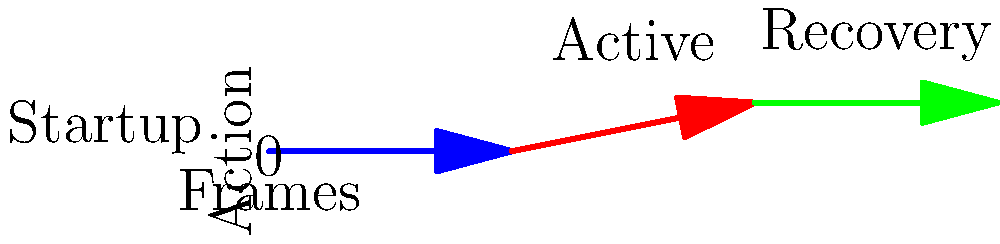In the frame data diagram for a fighting game character's move, what does the blue arrow represent, and how many frames does it last? To interpret this frame data diagram:

1. The x-axis represents frames, which are individual time units in fighting games.
2. The y-axis represents the action state of the move.
3. The diagram is divided into three parts, each represented by a different colored arrow:
   - Blue arrow: This is the first part of the move
   - Red arrow: This is the middle part of the move
   - Green arrow: This is the final part of the move

4. In fighting game terminology:
   - The blue arrow represents the "startup" frames
   - The red arrow represents the "active" frames
   - The green arrow represents the "recovery" frames

5. To determine how many frames the blue arrow (startup) lasts:
   - Count the number of frame units it spans on the x-axis
   - The blue arrow starts at frame 0 and ends at frame 5
   - Therefore, it lasts for 5 frames

Thus, the blue arrow represents the startup frames of the move, and it lasts for 5 frames.
Answer: Startup, 5 frames 